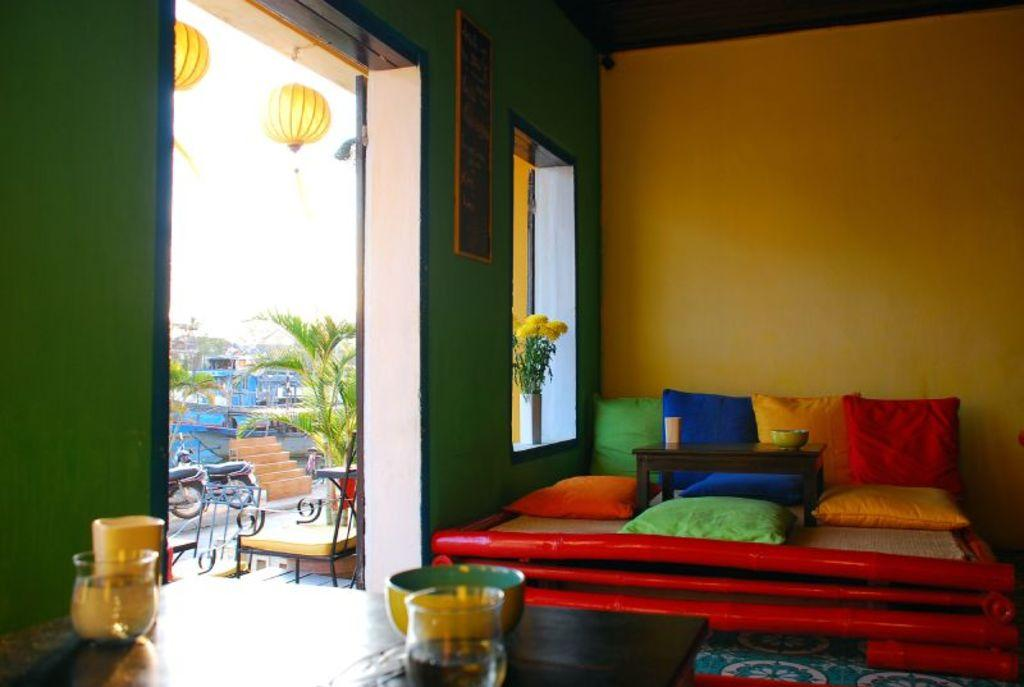What type of establishment is shown in the image? The image depicts a restaurant. How are the tables arranged in the restaurant? The tables in the restaurant are arranged for people to sit in a squatting position. What type of list can be seen on the wall in the image? There is no list visible on the wall in the image. 